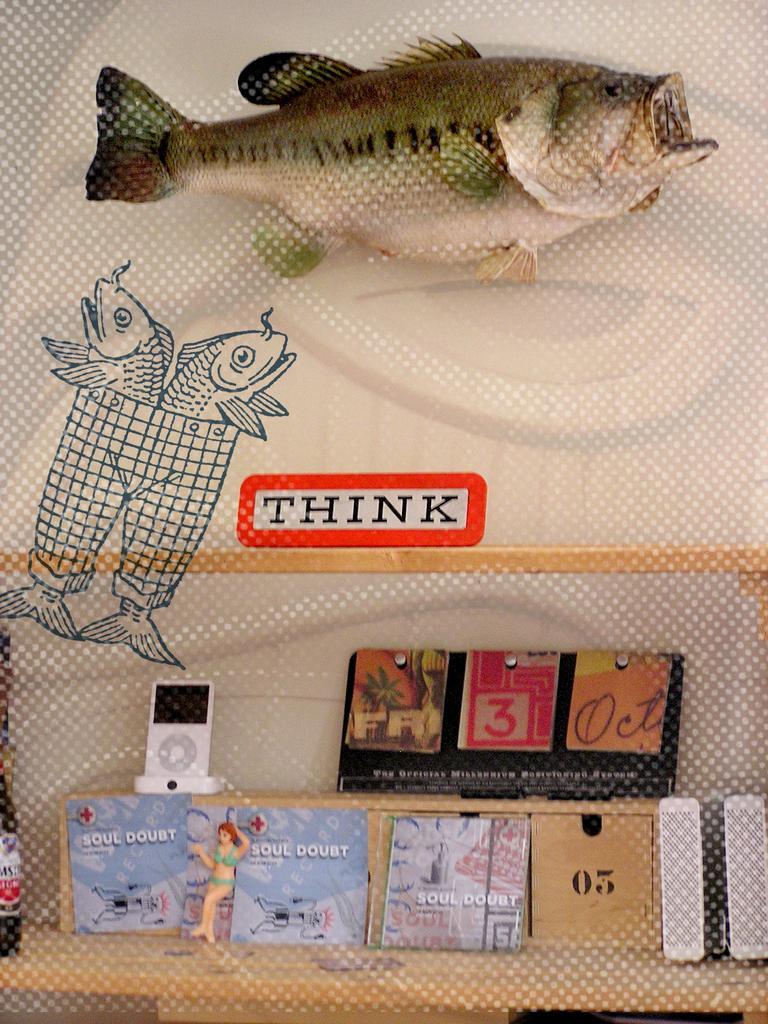How would you summarize this image in a sentence or two? This image looks like a poster. In this image we can see the images of fishes. There is a board with a text on it and there are a few objects. 